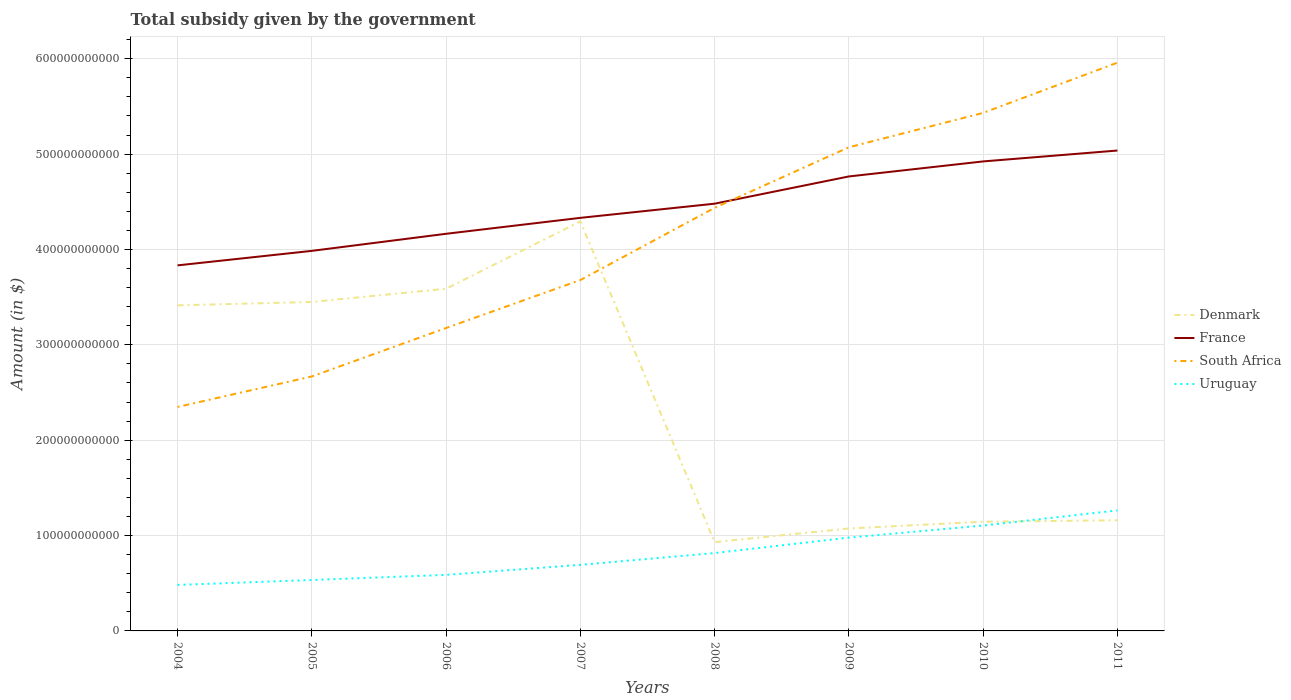Is the number of lines equal to the number of legend labels?
Ensure brevity in your answer.  Yes. Across all years, what is the maximum total revenue collected by the government in Denmark?
Ensure brevity in your answer.  9.31e+1. What is the total total revenue collected by the government in Denmark in the graph?
Give a very brief answer. -1.39e+1. What is the difference between the highest and the second highest total revenue collected by the government in France?
Keep it short and to the point. 1.20e+11. How many years are there in the graph?
Your answer should be compact. 8. What is the difference between two consecutive major ticks on the Y-axis?
Provide a succinct answer. 1.00e+11. Where does the legend appear in the graph?
Your answer should be very brief. Center right. How many legend labels are there?
Keep it short and to the point. 4. How are the legend labels stacked?
Your answer should be compact. Vertical. What is the title of the graph?
Offer a very short reply. Total subsidy given by the government. Does "Tunisia" appear as one of the legend labels in the graph?
Give a very brief answer. No. What is the label or title of the X-axis?
Offer a very short reply. Years. What is the label or title of the Y-axis?
Offer a very short reply. Amount (in $). What is the Amount (in $) in Denmark in 2004?
Your answer should be very brief. 3.41e+11. What is the Amount (in $) of France in 2004?
Provide a succinct answer. 3.83e+11. What is the Amount (in $) of South Africa in 2004?
Your answer should be compact. 2.35e+11. What is the Amount (in $) of Uruguay in 2004?
Provide a succinct answer. 4.82e+1. What is the Amount (in $) of Denmark in 2005?
Your answer should be compact. 3.45e+11. What is the Amount (in $) in France in 2005?
Provide a succinct answer. 3.99e+11. What is the Amount (in $) in South Africa in 2005?
Your answer should be very brief. 2.67e+11. What is the Amount (in $) in Uruguay in 2005?
Keep it short and to the point. 5.34e+1. What is the Amount (in $) in Denmark in 2006?
Your answer should be very brief. 3.59e+11. What is the Amount (in $) in France in 2006?
Provide a succinct answer. 4.16e+11. What is the Amount (in $) in South Africa in 2006?
Offer a very short reply. 3.18e+11. What is the Amount (in $) in Uruguay in 2006?
Provide a short and direct response. 5.88e+1. What is the Amount (in $) of Denmark in 2007?
Your answer should be compact. 4.29e+11. What is the Amount (in $) in France in 2007?
Provide a short and direct response. 4.33e+11. What is the Amount (in $) of South Africa in 2007?
Offer a terse response. 3.68e+11. What is the Amount (in $) in Uruguay in 2007?
Keep it short and to the point. 6.93e+1. What is the Amount (in $) in Denmark in 2008?
Your answer should be compact. 9.31e+1. What is the Amount (in $) in France in 2008?
Your response must be concise. 4.48e+11. What is the Amount (in $) in South Africa in 2008?
Your answer should be very brief. 4.44e+11. What is the Amount (in $) in Uruguay in 2008?
Your answer should be compact. 8.17e+1. What is the Amount (in $) in Denmark in 2009?
Provide a short and direct response. 1.07e+11. What is the Amount (in $) of France in 2009?
Your answer should be compact. 4.77e+11. What is the Amount (in $) of South Africa in 2009?
Provide a succinct answer. 5.07e+11. What is the Amount (in $) of Uruguay in 2009?
Keep it short and to the point. 9.79e+1. What is the Amount (in $) in Denmark in 2010?
Offer a terse response. 1.15e+11. What is the Amount (in $) of France in 2010?
Offer a very short reply. 4.92e+11. What is the Amount (in $) of South Africa in 2010?
Make the answer very short. 5.43e+11. What is the Amount (in $) of Uruguay in 2010?
Your answer should be very brief. 1.11e+11. What is the Amount (in $) of Denmark in 2011?
Offer a terse response. 1.16e+11. What is the Amount (in $) in France in 2011?
Provide a short and direct response. 5.04e+11. What is the Amount (in $) of South Africa in 2011?
Make the answer very short. 5.96e+11. What is the Amount (in $) of Uruguay in 2011?
Your response must be concise. 1.26e+11. Across all years, what is the maximum Amount (in $) of Denmark?
Provide a succinct answer. 4.29e+11. Across all years, what is the maximum Amount (in $) in France?
Provide a short and direct response. 5.04e+11. Across all years, what is the maximum Amount (in $) of South Africa?
Your answer should be compact. 5.96e+11. Across all years, what is the maximum Amount (in $) of Uruguay?
Offer a terse response. 1.26e+11. Across all years, what is the minimum Amount (in $) of Denmark?
Offer a very short reply. 9.31e+1. Across all years, what is the minimum Amount (in $) of France?
Give a very brief answer. 3.83e+11. Across all years, what is the minimum Amount (in $) of South Africa?
Your answer should be very brief. 2.35e+11. Across all years, what is the minimum Amount (in $) of Uruguay?
Offer a very short reply. 4.82e+1. What is the total Amount (in $) in Denmark in the graph?
Provide a succinct answer. 1.91e+12. What is the total Amount (in $) in France in the graph?
Offer a terse response. 3.55e+12. What is the total Amount (in $) in South Africa in the graph?
Offer a very short reply. 3.28e+12. What is the total Amount (in $) in Uruguay in the graph?
Provide a succinct answer. 6.46e+11. What is the difference between the Amount (in $) of Denmark in 2004 and that in 2005?
Provide a short and direct response. -3.54e+09. What is the difference between the Amount (in $) in France in 2004 and that in 2005?
Offer a very short reply. -1.52e+1. What is the difference between the Amount (in $) in South Africa in 2004 and that in 2005?
Ensure brevity in your answer.  -3.20e+1. What is the difference between the Amount (in $) of Uruguay in 2004 and that in 2005?
Make the answer very short. -5.17e+09. What is the difference between the Amount (in $) of Denmark in 2004 and that in 2006?
Provide a short and direct response. -1.74e+1. What is the difference between the Amount (in $) in France in 2004 and that in 2006?
Your response must be concise. -3.31e+1. What is the difference between the Amount (in $) in South Africa in 2004 and that in 2006?
Provide a short and direct response. -8.28e+1. What is the difference between the Amount (in $) in Uruguay in 2004 and that in 2006?
Provide a short and direct response. -1.06e+1. What is the difference between the Amount (in $) of Denmark in 2004 and that in 2007?
Provide a succinct answer. -8.80e+1. What is the difference between the Amount (in $) in France in 2004 and that in 2007?
Your answer should be compact. -4.98e+1. What is the difference between the Amount (in $) of South Africa in 2004 and that in 2007?
Your answer should be very brief. -1.33e+11. What is the difference between the Amount (in $) of Uruguay in 2004 and that in 2007?
Provide a succinct answer. -2.10e+1. What is the difference between the Amount (in $) in Denmark in 2004 and that in 2008?
Offer a terse response. 2.48e+11. What is the difference between the Amount (in $) in France in 2004 and that in 2008?
Give a very brief answer. -6.47e+1. What is the difference between the Amount (in $) of South Africa in 2004 and that in 2008?
Keep it short and to the point. -2.09e+11. What is the difference between the Amount (in $) of Uruguay in 2004 and that in 2008?
Your response must be concise. -3.34e+1. What is the difference between the Amount (in $) of Denmark in 2004 and that in 2009?
Your answer should be compact. 2.34e+11. What is the difference between the Amount (in $) of France in 2004 and that in 2009?
Give a very brief answer. -9.32e+1. What is the difference between the Amount (in $) of South Africa in 2004 and that in 2009?
Your response must be concise. -2.72e+11. What is the difference between the Amount (in $) of Uruguay in 2004 and that in 2009?
Your answer should be compact. -4.96e+1. What is the difference between the Amount (in $) of Denmark in 2004 and that in 2010?
Your response must be concise. 2.27e+11. What is the difference between the Amount (in $) of France in 2004 and that in 2010?
Your answer should be very brief. -1.09e+11. What is the difference between the Amount (in $) in South Africa in 2004 and that in 2010?
Provide a short and direct response. -3.08e+11. What is the difference between the Amount (in $) of Uruguay in 2004 and that in 2010?
Your response must be concise. -6.23e+1. What is the difference between the Amount (in $) in Denmark in 2004 and that in 2011?
Give a very brief answer. 2.25e+11. What is the difference between the Amount (in $) of France in 2004 and that in 2011?
Your response must be concise. -1.20e+11. What is the difference between the Amount (in $) of South Africa in 2004 and that in 2011?
Provide a succinct answer. -3.61e+11. What is the difference between the Amount (in $) of Uruguay in 2004 and that in 2011?
Make the answer very short. -7.81e+1. What is the difference between the Amount (in $) in Denmark in 2005 and that in 2006?
Give a very brief answer. -1.39e+1. What is the difference between the Amount (in $) in France in 2005 and that in 2006?
Ensure brevity in your answer.  -1.79e+1. What is the difference between the Amount (in $) in South Africa in 2005 and that in 2006?
Provide a short and direct response. -5.08e+1. What is the difference between the Amount (in $) of Uruguay in 2005 and that in 2006?
Your answer should be very brief. -5.38e+09. What is the difference between the Amount (in $) of Denmark in 2005 and that in 2007?
Provide a succinct answer. -8.45e+1. What is the difference between the Amount (in $) of France in 2005 and that in 2007?
Provide a succinct answer. -3.46e+1. What is the difference between the Amount (in $) of South Africa in 2005 and that in 2007?
Ensure brevity in your answer.  -1.01e+11. What is the difference between the Amount (in $) of Uruguay in 2005 and that in 2007?
Your answer should be compact. -1.58e+1. What is the difference between the Amount (in $) in Denmark in 2005 and that in 2008?
Keep it short and to the point. 2.52e+11. What is the difference between the Amount (in $) of France in 2005 and that in 2008?
Your answer should be compact. -4.95e+1. What is the difference between the Amount (in $) in South Africa in 2005 and that in 2008?
Give a very brief answer. -1.77e+11. What is the difference between the Amount (in $) in Uruguay in 2005 and that in 2008?
Provide a short and direct response. -2.82e+1. What is the difference between the Amount (in $) of Denmark in 2005 and that in 2009?
Keep it short and to the point. 2.38e+11. What is the difference between the Amount (in $) of France in 2005 and that in 2009?
Offer a terse response. -7.80e+1. What is the difference between the Amount (in $) in South Africa in 2005 and that in 2009?
Keep it short and to the point. -2.40e+11. What is the difference between the Amount (in $) in Uruguay in 2005 and that in 2009?
Your answer should be compact. -4.44e+1. What is the difference between the Amount (in $) of Denmark in 2005 and that in 2010?
Provide a short and direct response. 2.30e+11. What is the difference between the Amount (in $) in France in 2005 and that in 2010?
Provide a succinct answer. -9.38e+1. What is the difference between the Amount (in $) of South Africa in 2005 and that in 2010?
Provide a succinct answer. -2.76e+11. What is the difference between the Amount (in $) of Uruguay in 2005 and that in 2010?
Your response must be concise. -5.71e+1. What is the difference between the Amount (in $) of Denmark in 2005 and that in 2011?
Keep it short and to the point. 2.29e+11. What is the difference between the Amount (in $) in France in 2005 and that in 2011?
Keep it short and to the point. -1.05e+11. What is the difference between the Amount (in $) of South Africa in 2005 and that in 2011?
Make the answer very short. -3.29e+11. What is the difference between the Amount (in $) of Uruguay in 2005 and that in 2011?
Give a very brief answer. -7.30e+1. What is the difference between the Amount (in $) of Denmark in 2006 and that in 2007?
Give a very brief answer. -7.06e+1. What is the difference between the Amount (in $) in France in 2006 and that in 2007?
Your answer should be very brief. -1.67e+1. What is the difference between the Amount (in $) in South Africa in 2006 and that in 2007?
Your response must be concise. -5.03e+1. What is the difference between the Amount (in $) of Uruguay in 2006 and that in 2007?
Offer a very short reply. -1.05e+1. What is the difference between the Amount (in $) of Denmark in 2006 and that in 2008?
Keep it short and to the point. 2.66e+11. What is the difference between the Amount (in $) in France in 2006 and that in 2008?
Your answer should be compact. -3.16e+1. What is the difference between the Amount (in $) in South Africa in 2006 and that in 2008?
Ensure brevity in your answer.  -1.26e+11. What is the difference between the Amount (in $) in Uruguay in 2006 and that in 2008?
Make the answer very short. -2.29e+1. What is the difference between the Amount (in $) of Denmark in 2006 and that in 2009?
Provide a succinct answer. 2.51e+11. What is the difference between the Amount (in $) in France in 2006 and that in 2009?
Give a very brief answer. -6.01e+1. What is the difference between the Amount (in $) of South Africa in 2006 and that in 2009?
Keep it short and to the point. -1.90e+11. What is the difference between the Amount (in $) in Uruguay in 2006 and that in 2009?
Your response must be concise. -3.91e+1. What is the difference between the Amount (in $) in Denmark in 2006 and that in 2010?
Give a very brief answer. 2.44e+11. What is the difference between the Amount (in $) in France in 2006 and that in 2010?
Ensure brevity in your answer.  -7.59e+1. What is the difference between the Amount (in $) of South Africa in 2006 and that in 2010?
Keep it short and to the point. -2.26e+11. What is the difference between the Amount (in $) in Uruguay in 2006 and that in 2010?
Offer a very short reply. -5.17e+1. What is the difference between the Amount (in $) of Denmark in 2006 and that in 2011?
Provide a short and direct response. 2.43e+11. What is the difference between the Amount (in $) of France in 2006 and that in 2011?
Offer a very short reply. -8.73e+1. What is the difference between the Amount (in $) in South Africa in 2006 and that in 2011?
Your answer should be compact. -2.78e+11. What is the difference between the Amount (in $) of Uruguay in 2006 and that in 2011?
Keep it short and to the point. -6.76e+1. What is the difference between the Amount (in $) in Denmark in 2007 and that in 2008?
Offer a terse response. 3.36e+11. What is the difference between the Amount (in $) of France in 2007 and that in 2008?
Your answer should be very brief. -1.49e+1. What is the difference between the Amount (in $) in South Africa in 2007 and that in 2008?
Make the answer very short. -7.57e+1. What is the difference between the Amount (in $) of Uruguay in 2007 and that in 2008?
Provide a succinct answer. -1.24e+1. What is the difference between the Amount (in $) in Denmark in 2007 and that in 2009?
Your answer should be very brief. 3.22e+11. What is the difference between the Amount (in $) of France in 2007 and that in 2009?
Your answer should be compact. -4.34e+1. What is the difference between the Amount (in $) of South Africa in 2007 and that in 2009?
Keep it short and to the point. -1.39e+11. What is the difference between the Amount (in $) of Uruguay in 2007 and that in 2009?
Your response must be concise. -2.86e+1. What is the difference between the Amount (in $) of Denmark in 2007 and that in 2010?
Keep it short and to the point. 3.15e+11. What is the difference between the Amount (in $) in France in 2007 and that in 2010?
Your answer should be very brief. -5.92e+1. What is the difference between the Amount (in $) of South Africa in 2007 and that in 2010?
Make the answer very short. -1.75e+11. What is the difference between the Amount (in $) in Uruguay in 2007 and that in 2010?
Ensure brevity in your answer.  -4.12e+1. What is the difference between the Amount (in $) of Denmark in 2007 and that in 2011?
Offer a terse response. 3.13e+11. What is the difference between the Amount (in $) of France in 2007 and that in 2011?
Make the answer very short. -7.06e+1. What is the difference between the Amount (in $) in South Africa in 2007 and that in 2011?
Offer a terse response. -2.28e+11. What is the difference between the Amount (in $) of Uruguay in 2007 and that in 2011?
Offer a terse response. -5.71e+1. What is the difference between the Amount (in $) in Denmark in 2008 and that in 2009?
Keep it short and to the point. -1.43e+1. What is the difference between the Amount (in $) of France in 2008 and that in 2009?
Your answer should be compact. -2.86e+1. What is the difference between the Amount (in $) in South Africa in 2008 and that in 2009?
Your answer should be compact. -6.35e+1. What is the difference between the Amount (in $) of Uruguay in 2008 and that in 2009?
Give a very brief answer. -1.62e+1. What is the difference between the Amount (in $) in Denmark in 2008 and that in 2010?
Your response must be concise. -2.14e+1. What is the difference between the Amount (in $) of France in 2008 and that in 2010?
Offer a very short reply. -4.43e+1. What is the difference between the Amount (in $) in South Africa in 2008 and that in 2010?
Offer a very short reply. -9.96e+1. What is the difference between the Amount (in $) in Uruguay in 2008 and that in 2010?
Your answer should be compact. -2.89e+1. What is the difference between the Amount (in $) in Denmark in 2008 and that in 2011?
Make the answer very short. -2.29e+1. What is the difference between the Amount (in $) in France in 2008 and that in 2011?
Give a very brief answer. -5.57e+1. What is the difference between the Amount (in $) in South Africa in 2008 and that in 2011?
Make the answer very short. -1.52e+11. What is the difference between the Amount (in $) in Uruguay in 2008 and that in 2011?
Make the answer very short. -4.47e+1. What is the difference between the Amount (in $) in Denmark in 2009 and that in 2010?
Offer a terse response. -7.08e+09. What is the difference between the Amount (in $) in France in 2009 and that in 2010?
Your response must be concise. -1.57e+1. What is the difference between the Amount (in $) of South Africa in 2009 and that in 2010?
Your answer should be very brief. -3.61e+1. What is the difference between the Amount (in $) of Uruguay in 2009 and that in 2010?
Provide a short and direct response. -1.26e+1. What is the difference between the Amount (in $) in Denmark in 2009 and that in 2011?
Offer a very short reply. -8.61e+09. What is the difference between the Amount (in $) of France in 2009 and that in 2011?
Your response must be concise. -2.72e+1. What is the difference between the Amount (in $) in South Africa in 2009 and that in 2011?
Provide a short and direct response. -8.87e+1. What is the difference between the Amount (in $) of Uruguay in 2009 and that in 2011?
Your answer should be very brief. -2.85e+1. What is the difference between the Amount (in $) of Denmark in 2010 and that in 2011?
Give a very brief answer. -1.53e+09. What is the difference between the Amount (in $) of France in 2010 and that in 2011?
Provide a short and direct response. -1.14e+1. What is the difference between the Amount (in $) in South Africa in 2010 and that in 2011?
Make the answer very short. -5.26e+1. What is the difference between the Amount (in $) of Uruguay in 2010 and that in 2011?
Give a very brief answer. -1.59e+1. What is the difference between the Amount (in $) in Denmark in 2004 and the Amount (in $) in France in 2005?
Your answer should be very brief. -5.71e+1. What is the difference between the Amount (in $) in Denmark in 2004 and the Amount (in $) in South Africa in 2005?
Give a very brief answer. 7.46e+1. What is the difference between the Amount (in $) of Denmark in 2004 and the Amount (in $) of Uruguay in 2005?
Your response must be concise. 2.88e+11. What is the difference between the Amount (in $) of France in 2004 and the Amount (in $) of South Africa in 2005?
Keep it short and to the point. 1.16e+11. What is the difference between the Amount (in $) of France in 2004 and the Amount (in $) of Uruguay in 2005?
Keep it short and to the point. 3.30e+11. What is the difference between the Amount (in $) in South Africa in 2004 and the Amount (in $) in Uruguay in 2005?
Ensure brevity in your answer.  1.81e+11. What is the difference between the Amount (in $) of Denmark in 2004 and the Amount (in $) of France in 2006?
Give a very brief answer. -7.50e+1. What is the difference between the Amount (in $) in Denmark in 2004 and the Amount (in $) in South Africa in 2006?
Provide a short and direct response. 2.38e+1. What is the difference between the Amount (in $) of Denmark in 2004 and the Amount (in $) of Uruguay in 2006?
Provide a succinct answer. 2.83e+11. What is the difference between the Amount (in $) of France in 2004 and the Amount (in $) of South Africa in 2006?
Your answer should be very brief. 6.57e+1. What is the difference between the Amount (in $) of France in 2004 and the Amount (in $) of Uruguay in 2006?
Offer a terse response. 3.25e+11. What is the difference between the Amount (in $) of South Africa in 2004 and the Amount (in $) of Uruguay in 2006?
Your response must be concise. 1.76e+11. What is the difference between the Amount (in $) in Denmark in 2004 and the Amount (in $) in France in 2007?
Your answer should be compact. -9.17e+1. What is the difference between the Amount (in $) in Denmark in 2004 and the Amount (in $) in South Africa in 2007?
Offer a terse response. -2.65e+1. What is the difference between the Amount (in $) of Denmark in 2004 and the Amount (in $) of Uruguay in 2007?
Offer a very short reply. 2.72e+11. What is the difference between the Amount (in $) in France in 2004 and the Amount (in $) in South Africa in 2007?
Provide a short and direct response. 1.54e+1. What is the difference between the Amount (in $) of France in 2004 and the Amount (in $) of Uruguay in 2007?
Provide a short and direct response. 3.14e+11. What is the difference between the Amount (in $) in South Africa in 2004 and the Amount (in $) in Uruguay in 2007?
Provide a succinct answer. 1.66e+11. What is the difference between the Amount (in $) of Denmark in 2004 and the Amount (in $) of France in 2008?
Ensure brevity in your answer.  -1.07e+11. What is the difference between the Amount (in $) in Denmark in 2004 and the Amount (in $) in South Africa in 2008?
Your answer should be very brief. -1.02e+11. What is the difference between the Amount (in $) in Denmark in 2004 and the Amount (in $) in Uruguay in 2008?
Offer a very short reply. 2.60e+11. What is the difference between the Amount (in $) in France in 2004 and the Amount (in $) in South Africa in 2008?
Your response must be concise. -6.03e+1. What is the difference between the Amount (in $) of France in 2004 and the Amount (in $) of Uruguay in 2008?
Give a very brief answer. 3.02e+11. What is the difference between the Amount (in $) of South Africa in 2004 and the Amount (in $) of Uruguay in 2008?
Provide a short and direct response. 1.53e+11. What is the difference between the Amount (in $) of Denmark in 2004 and the Amount (in $) of France in 2009?
Give a very brief answer. -1.35e+11. What is the difference between the Amount (in $) of Denmark in 2004 and the Amount (in $) of South Africa in 2009?
Make the answer very short. -1.66e+11. What is the difference between the Amount (in $) in Denmark in 2004 and the Amount (in $) in Uruguay in 2009?
Give a very brief answer. 2.44e+11. What is the difference between the Amount (in $) of France in 2004 and the Amount (in $) of South Africa in 2009?
Offer a terse response. -1.24e+11. What is the difference between the Amount (in $) in France in 2004 and the Amount (in $) in Uruguay in 2009?
Ensure brevity in your answer.  2.85e+11. What is the difference between the Amount (in $) in South Africa in 2004 and the Amount (in $) in Uruguay in 2009?
Your response must be concise. 1.37e+11. What is the difference between the Amount (in $) of Denmark in 2004 and the Amount (in $) of France in 2010?
Make the answer very short. -1.51e+11. What is the difference between the Amount (in $) in Denmark in 2004 and the Amount (in $) in South Africa in 2010?
Ensure brevity in your answer.  -2.02e+11. What is the difference between the Amount (in $) in Denmark in 2004 and the Amount (in $) in Uruguay in 2010?
Your answer should be compact. 2.31e+11. What is the difference between the Amount (in $) in France in 2004 and the Amount (in $) in South Africa in 2010?
Your answer should be compact. -1.60e+11. What is the difference between the Amount (in $) in France in 2004 and the Amount (in $) in Uruguay in 2010?
Your answer should be very brief. 2.73e+11. What is the difference between the Amount (in $) of South Africa in 2004 and the Amount (in $) of Uruguay in 2010?
Your answer should be compact. 1.24e+11. What is the difference between the Amount (in $) in Denmark in 2004 and the Amount (in $) in France in 2011?
Provide a succinct answer. -1.62e+11. What is the difference between the Amount (in $) in Denmark in 2004 and the Amount (in $) in South Africa in 2011?
Keep it short and to the point. -2.54e+11. What is the difference between the Amount (in $) of Denmark in 2004 and the Amount (in $) of Uruguay in 2011?
Make the answer very short. 2.15e+11. What is the difference between the Amount (in $) of France in 2004 and the Amount (in $) of South Africa in 2011?
Your answer should be compact. -2.13e+11. What is the difference between the Amount (in $) of France in 2004 and the Amount (in $) of Uruguay in 2011?
Keep it short and to the point. 2.57e+11. What is the difference between the Amount (in $) in South Africa in 2004 and the Amount (in $) in Uruguay in 2011?
Offer a terse response. 1.08e+11. What is the difference between the Amount (in $) of Denmark in 2005 and the Amount (in $) of France in 2006?
Provide a short and direct response. -7.15e+1. What is the difference between the Amount (in $) in Denmark in 2005 and the Amount (in $) in South Africa in 2006?
Offer a terse response. 2.73e+1. What is the difference between the Amount (in $) in Denmark in 2005 and the Amount (in $) in Uruguay in 2006?
Your response must be concise. 2.86e+11. What is the difference between the Amount (in $) in France in 2005 and the Amount (in $) in South Africa in 2006?
Make the answer very short. 8.09e+1. What is the difference between the Amount (in $) in France in 2005 and the Amount (in $) in Uruguay in 2006?
Make the answer very short. 3.40e+11. What is the difference between the Amount (in $) in South Africa in 2005 and the Amount (in $) in Uruguay in 2006?
Your response must be concise. 2.08e+11. What is the difference between the Amount (in $) in Denmark in 2005 and the Amount (in $) in France in 2007?
Keep it short and to the point. -8.82e+1. What is the difference between the Amount (in $) in Denmark in 2005 and the Amount (in $) in South Africa in 2007?
Give a very brief answer. -2.30e+1. What is the difference between the Amount (in $) of Denmark in 2005 and the Amount (in $) of Uruguay in 2007?
Give a very brief answer. 2.76e+11. What is the difference between the Amount (in $) in France in 2005 and the Amount (in $) in South Africa in 2007?
Offer a very short reply. 3.06e+1. What is the difference between the Amount (in $) in France in 2005 and the Amount (in $) in Uruguay in 2007?
Offer a very short reply. 3.29e+11. What is the difference between the Amount (in $) in South Africa in 2005 and the Amount (in $) in Uruguay in 2007?
Ensure brevity in your answer.  1.98e+11. What is the difference between the Amount (in $) of Denmark in 2005 and the Amount (in $) of France in 2008?
Your answer should be compact. -1.03e+11. What is the difference between the Amount (in $) of Denmark in 2005 and the Amount (in $) of South Africa in 2008?
Provide a succinct answer. -9.87e+1. What is the difference between the Amount (in $) of Denmark in 2005 and the Amount (in $) of Uruguay in 2008?
Keep it short and to the point. 2.63e+11. What is the difference between the Amount (in $) of France in 2005 and the Amount (in $) of South Africa in 2008?
Give a very brief answer. -4.51e+1. What is the difference between the Amount (in $) in France in 2005 and the Amount (in $) in Uruguay in 2008?
Offer a terse response. 3.17e+11. What is the difference between the Amount (in $) in South Africa in 2005 and the Amount (in $) in Uruguay in 2008?
Your response must be concise. 1.85e+11. What is the difference between the Amount (in $) of Denmark in 2005 and the Amount (in $) of France in 2009?
Provide a short and direct response. -1.32e+11. What is the difference between the Amount (in $) of Denmark in 2005 and the Amount (in $) of South Africa in 2009?
Provide a succinct answer. -1.62e+11. What is the difference between the Amount (in $) of Denmark in 2005 and the Amount (in $) of Uruguay in 2009?
Make the answer very short. 2.47e+11. What is the difference between the Amount (in $) of France in 2005 and the Amount (in $) of South Africa in 2009?
Offer a very short reply. -1.09e+11. What is the difference between the Amount (in $) in France in 2005 and the Amount (in $) in Uruguay in 2009?
Offer a terse response. 3.01e+11. What is the difference between the Amount (in $) in South Africa in 2005 and the Amount (in $) in Uruguay in 2009?
Provide a short and direct response. 1.69e+11. What is the difference between the Amount (in $) of Denmark in 2005 and the Amount (in $) of France in 2010?
Keep it short and to the point. -1.47e+11. What is the difference between the Amount (in $) of Denmark in 2005 and the Amount (in $) of South Africa in 2010?
Offer a very short reply. -1.98e+11. What is the difference between the Amount (in $) in Denmark in 2005 and the Amount (in $) in Uruguay in 2010?
Your response must be concise. 2.34e+11. What is the difference between the Amount (in $) in France in 2005 and the Amount (in $) in South Africa in 2010?
Provide a short and direct response. -1.45e+11. What is the difference between the Amount (in $) in France in 2005 and the Amount (in $) in Uruguay in 2010?
Provide a short and direct response. 2.88e+11. What is the difference between the Amount (in $) of South Africa in 2005 and the Amount (in $) of Uruguay in 2010?
Your answer should be compact. 1.56e+11. What is the difference between the Amount (in $) in Denmark in 2005 and the Amount (in $) in France in 2011?
Give a very brief answer. -1.59e+11. What is the difference between the Amount (in $) in Denmark in 2005 and the Amount (in $) in South Africa in 2011?
Offer a very short reply. -2.51e+11. What is the difference between the Amount (in $) in Denmark in 2005 and the Amount (in $) in Uruguay in 2011?
Your answer should be compact. 2.19e+11. What is the difference between the Amount (in $) of France in 2005 and the Amount (in $) of South Africa in 2011?
Keep it short and to the point. -1.97e+11. What is the difference between the Amount (in $) in France in 2005 and the Amount (in $) in Uruguay in 2011?
Offer a very short reply. 2.72e+11. What is the difference between the Amount (in $) of South Africa in 2005 and the Amount (in $) of Uruguay in 2011?
Keep it short and to the point. 1.40e+11. What is the difference between the Amount (in $) of Denmark in 2006 and the Amount (in $) of France in 2007?
Make the answer very short. -7.43e+1. What is the difference between the Amount (in $) of Denmark in 2006 and the Amount (in $) of South Africa in 2007?
Offer a very short reply. -9.12e+09. What is the difference between the Amount (in $) in Denmark in 2006 and the Amount (in $) in Uruguay in 2007?
Offer a terse response. 2.90e+11. What is the difference between the Amount (in $) in France in 2006 and the Amount (in $) in South Africa in 2007?
Offer a very short reply. 4.85e+1. What is the difference between the Amount (in $) in France in 2006 and the Amount (in $) in Uruguay in 2007?
Provide a short and direct response. 3.47e+11. What is the difference between the Amount (in $) in South Africa in 2006 and the Amount (in $) in Uruguay in 2007?
Your response must be concise. 2.48e+11. What is the difference between the Amount (in $) of Denmark in 2006 and the Amount (in $) of France in 2008?
Ensure brevity in your answer.  -8.92e+1. What is the difference between the Amount (in $) in Denmark in 2006 and the Amount (in $) in South Africa in 2008?
Keep it short and to the point. -8.49e+1. What is the difference between the Amount (in $) in Denmark in 2006 and the Amount (in $) in Uruguay in 2008?
Offer a terse response. 2.77e+11. What is the difference between the Amount (in $) in France in 2006 and the Amount (in $) in South Africa in 2008?
Your answer should be compact. -2.72e+1. What is the difference between the Amount (in $) in France in 2006 and the Amount (in $) in Uruguay in 2008?
Offer a very short reply. 3.35e+11. What is the difference between the Amount (in $) of South Africa in 2006 and the Amount (in $) of Uruguay in 2008?
Keep it short and to the point. 2.36e+11. What is the difference between the Amount (in $) of Denmark in 2006 and the Amount (in $) of France in 2009?
Your answer should be compact. -1.18e+11. What is the difference between the Amount (in $) in Denmark in 2006 and the Amount (in $) in South Africa in 2009?
Offer a terse response. -1.48e+11. What is the difference between the Amount (in $) in Denmark in 2006 and the Amount (in $) in Uruguay in 2009?
Offer a very short reply. 2.61e+11. What is the difference between the Amount (in $) in France in 2006 and the Amount (in $) in South Africa in 2009?
Give a very brief answer. -9.07e+1. What is the difference between the Amount (in $) in France in 2006 and the Amount (in $) in Uruguay in 2009?
Give a very brief answer. 3.19e+11. What is the difference between the Amount (in $) in South Africa in 2006 and the Amount (in $) in Uruguay in 2009?
Provide a short and direct response. 2.20e+11. What is the difference between the Amount (in $) of Denmark in 2006 and the Amount (in $) of France in 2010?
Keep it short and to the point. -1.34e+11. What is the difference between the Amount (in $) in Denmark in 2006 and the Amount (in $) in South Africa in 2010?
Provide a succinct answer. -1.84e+11. What is the difference between the Amount (in $) of Denmark in 2006 and the Amount (in $) of Uruguay in 2010?
Your response must be concise. 2.48e+11. What is the difference between the Amount (in $) of France in 2006 and the Amount (in $) of South Africa in 2010?
Your answer should be very brief. -1.27e+11. What is the difference between the Amount (in $) of France in 2006 and the Amount (in $) of Uruguay in 2010?
Your answer should be very brief. 3.06e+11. What is the difference between the Amount (in $) in South Africa in 2006 and the Amount (in $) in Uruguay in 2010?
Your answer should be very brief. 2.07e+11. What is the difference between the Amount (in $) in Denmark in 2006 and the Amount (in $) in France in 2011?
Your answer should be compact. -1.45e+11. What is the difference between the Amount (in $) of Denmark in 2006 and the Amount (in $) of South Africa in 2011?
Ensure brevity in your answer.  -2.37e+11. What is the difference between the Amount (in $) in Denmark in 2006 and the Amount (in $) in Uruguay in 2011?
Offer a very short reply. 2.32e+11. What is the difference between the Amount (in $) of France in 2006 and the Amount (in $) of South Africa in 2011?
Give a very brief answer. -1.79e+11. What is the difference between the Amount (in $) in France in 2006 and the Amount (in $) in Uruguay in 2011?
Keep it short and to the point. 2.90e+11. What is the difference between the Amount (in $) of South Africa in 2006 and the Amount (in $) of Uruguay in 2011?
Give a very brief answer. 1.91e+11. What is the difference between the Amount (in $) of Denmark in 2007 and the Amount (in $) of France in 2008?
Your answer should be very brief. -1.86e+1. What is the difference between the Amount (in $) in Denmark in 2007 and the Amount (in $) in South Africa in 2008?
Offer a very short reply. -1.42e+1. What is the difference between the Amount (in $) of Denmark in 2007 and the Amount (in $) of Uruguay in 2008?
Offer a terse response. 3.48e+11. What is the difference between the Amount (in $) of France in 2007 and the Amount (in $) of South Africa in 2008?
Make the answer very short. -1.05e+1. What is the difference between the Amount (in $) in France in 2007 and the Amount (in $) in Uruguay in 2008?
Offer a terse response. 3.51e+11. What is the difference between the Amount (in $) in South Africa in 2007 and the Amount (in $) in Uruguay in 2008?
Your answer should be compact. 2.86e+11. What is the difference between the Amount (in $) in Denmark in 2007 and the Amount (in $) in France in 2009?
Keep it short and to the point. -4.71e+1. What is the difference between the Amount (in $) of Denmark in 2007 and the Amount (in $) of South Africa in 2009?
Provide a short and direct response. -7.77e+1. What is the difference between the Amount (in $) in Denmark in 2007 and the Amount (in $) in Uruguay in 2009?
Keep it short and to the point. 3.32e+11. What is the difference between the Amount (in $) in France in 2007 and the Amount (in $) in South Africa in 2009?
Make the answer very short. -7.40e+1. What is the difference between the Amount (in $) in France in 2007 and the Amount (in $) in Uruguay in 2009?
Offer a very short reply. 3.35e+11. What is the difference between the Amount (in $) of South Africa in 2007 and the Amount (in $) of Uruguay in 2009?
Give a very brief answer. 2.70e+11. What is the difference between the Amount (in $) of Denmark in 2007 and the Amount (in $) of France in 2010?
Give a very brief answer. -6.29e+1. What is the difference between the Amount (in $) of Denmark in 2007 and the Amount (in $) of South Africa in 2010?
Provide a short and direct response. -1.14e+11. What is the difference between the Amount (in $) of Denmark in 2007 and the Amount (in $) of Uruguay in 2010?
Keep it short and to the point. 3.19e+11. What is the difference between the Amount (in $) in France in 2007 and the Amount (in $) in South Africa in 2010?
Your answer should be compact. -1.10e+11. What is the difference between the Amount (in $) in France in 2007 and the Amount (in $) in Uruguay in 2010?
Offer a terse response. 3.23e+11. What is the difference between the Amount (in $) of South Africa in 2007 and the Amount (in $) of Uruguay in 2010?
Keep it short and to the point. 2.57e+11. What is the difference between the Amount (in $) of Denmark in 2007 and the Amount (in $) of France in 2011?
Offer a terse response. -7.43e+1. What is the difference between the Amount (in $) of Denmark in 2007 and the Amount (in $) of South Africa in 2011?
Give a very brief answer. -1.66e+11. What is the difference between the Amount (in $) of Denmark in 2007 and the Amount (in $) of Uruguay in 2011?
Keep it short and to the point. 3.03e+11. What is the difference between the Amount (in $) in France in 2007 and the Amount (in $) in South Africa in 2011?
Your answer should be very brief. -1.63e+11. What is the difference between the Amount (in $) in France in 2007 and the Amount (in $) in Uruguay in 2011?
Offer a terse response. 3.07e+11. What is the difference between the Amount (in $) in South Africa in 2007 and the Amount (in $) in Uruguay in 2011?
Your answer should be very brief. 2.42e+11. What is the difference between the Amount (in $) of Denmark in 2008 and the Amount (in $) of France in 2009?
Make the answer very short. -3.83e+11. What is the difference between the Amount (in $) in Denmark in 2008 and the Amount (in $) in South Africa in 2009?
Give a very brief answer. -4.14e+11. What is the difference between the Amount (in $) in Denmark in 2008 and the Amount (in $) in Uruguay in 2009?
Offer a terse response. -4.73e+09. What is the difference between the Amount (in $) in France in 2008 and the Amount (in $) in South Africa in 2009?
Provide a succinct answer. -5.92e+1. What is the difference between the Amount (in $) of France in 2008 and the Amount (in $) of Uruguay in 2009?
Ensure brevity in your answer.  3.50e+11. What is the difference between the Amount (in $) of South Africa in 2008 and the Amount (in $) of Uruguay in 2009?
Offer a terse response. 3.46e+11. What is the difference between the Amount (in $) in Denmark in 2008 and the Amount (in $) in France in 2010?
Your answer should be very brief. -3.99e+11. What is the difference between the Amount (in $) of Denmark in 2008 and the Amount (in $) of South Africa in 2010?
Make the answer very short. -4.50e+11. What is the difference between the Amount (in $) of Denmark in 2008 and the Amount (in $) of Uruguay in 2010?
Make the answer very short. -1.74e+1. What is the difference between the Amount (in $) in France in 2008 and the Amount (in $) in South Africa in 2010?
Give a very brief answer. -9.52e+1. What is the difference between the Amount (in $) in France in 2008 and the Amount (in $) in Uruguay in 2010?
Provide a succinct answer. 3.37e+11. What is the difference between the Amount (in $) of South Africa in 2008 and the Amount (in $) of Uruguay in 2010?
Your answer should be compact. 3.33e+11. What is the difference between the Amount (in $) in Denmark in 2008 and the Amount (in $) in France in 2011?
Your answer should be very brief. -4.11e+11. What is the difference between the Amount (in $) in Denmark in 2008 and the Amount (in $) in South Africa in 2011?
Give a very brief answer. -5.03e+11. What is the difference between the Amount (in $) in Denmark in 2008 and the Amount (in $) in Uruguay in 2011?
Give a very brief answer. -3.33e+1. What is the difference between the Amount (in $) in France in 2008 and the Amount (in $) in South Africa in 2011?
Keep it short and to the point. -1.48e+11. What is the difference between the Amount (in $) in France in 2008 and the Amount (in $) in Uruguay in 2011?
Offer a terse response. 3.22e+11. What is the difference between the Amount (in $) in South Africa in 2008 and the Amount (in $) in Uruguay in 2011?
Give a very brief answer. 3.17e+11. What is the difference between the Amount (in $) in Denmark in 2009 and the Amount (in $) in France in 2010?
Your answer should be very brief. -3.85e+11. What is the difference between the Amount (in $) in Denmark in 2009 and the Amount (in $) in South Africa in 2010?
Provide a succinct answer. -4.36e+11. What is the difference between the Amount (in $) of Denmark in 2009 and the Amount (in $) of Uruguay in 2010?
Keep it short and to the point. -3.08e+09. What is the difference between the Amount (in $) of France in 2009 and the Amount (in $) of South Africa in 2010?
Provide a short and direct response. -6.67e+1. What is the difference between the Amount (in $) in France in 2009 and the Amount (in $) in Uruguay in 2010?
Provide a succinct answer. 3.66e+11. What is the difference between the Amount (in $) of South Africa in 2009 and the Amount (in $) of Uruguay in 2010?
Ensure brevity in your answer.  3.97e+11. What is the difference between the Amount (in $) in Denmark in 2009 and the Amount (in $) in France in 2011?
Your answer should be very brief. -3.96e+11. What is the difference between the Amount (in $) in Denmark in 2009 and the Amount (in $) in South Africa in 2011?
Provide a short and direct response. -4.88e+11. What is the difference between the Amount (in $) in Denmark in 2009 and the Amount (in $) in Uruguay in 2011?
Ensure brevity in your answer.  -1.90e+1. What is the difference between the Amount (in $) in France in 2009 and the Amount (in $) in South Africa in 2011?
Offer a very short reply. -1.19e+11. What is the difference between the Amount (in $) of France in 2009 and the Amount (in $) of Uruguay in 2011?
Your response must be concise. 3.50e+11. What is the difference between the Amount (in $) of South Africa in 2009 and the Amount (in $) of Uruguay in 2011?
Make the answer very short. 3.81e+11. What is the difference between the Amount (in $) of Denmark in 2010 and the Amount (in $) of France in 2011?
Give a very brief answer. -3.89e+11. What is the difference between the Amount (in $) of Denmark in 2010 and the Amount (in $) of South Africa in 2011?
Give a very brief answer. -4.81e+11. What is the difference between the Amount (in $) in Denmark in 2010 and the Amount (in $) in Uruguay in 2011?
Offer a terse response. -1.19e+1. What is the difference between the Amount (in $) in France in 2010 and the Amount (in $) in South Africa in 2011?
Your response must be concise. -1.04e+11. What is the difference between the Amount (in $) in France in 2010 and the Amount (in $) in Uruguay in 2011?
Provide a succinct answer. 3.66e+11. What is the difference between the Amount (in $) in South Africa in 2010 and the Amount (in $) in Uruguay in 2011?
Your answer should be compact. 4.17e+11. What is the average Amount (in $) in Denmark per year?
Your response must be concise. 2.38e+11. What is the average Amount (in $) in France per year?
Ensure brevity in your answer.  4.44e+11. What is the average Amount (in $) of South Africa per year?
Your answer should be compact. 4.10e+11. What is the average Amount (in $) of Uruguay per year?
Keep it short and to the point. 8.08e+1. In the year 2004, what is the difference between the Amount (in $) in Denmark and Amount (in $) in France?
Your answer should be compact. -4.19e+1. In the year 2004, what is the difference between the Amount (in $) of Denmark and Amount (in $) of South Africa?
Ensure brevity in your answer.  1.07e+11. In the year 2004, what is the difference between the Amount (in $) of Denmark and Amount (in $) of Uruguay?
Your answer should be compact. 2.93e+11. In the year 2004, what is the difference between the Amount (in $) of France and Amount (in $) of South Africa?
Your answer should be compact. 1.48e+11. In the year 2004, what is the difference between the Amount (in $) in France and Amount (in $) in Uruguay?
Your answer should be compact. 3.35e+11. In the year 2004, what is the difference between the Amount (in $) in South Africa and Amount (in $) in Uruguay?
Make the answer very short. 1.87e+11. In the year 2005, what is the difference between the Amount (in $) in Denmark and Amount (in $) in France?
Your answer should be compact. -5.36e+1. In the year 2005, what is the difference between the Amount (in $) in Denmark and Amount (in $) in South Africa?
Give a very brief answer. 7.81e+1. In the year 2005, what is the difference between the Amount (in $) of Denmark and Amount (in $) of Uruguay?
Ensure brevity in your answer.  2.92e+11. In the year 2005, what is the difference between the Amount (in $) of France and Amount (in $) of South Africa?
Keep it short and to the point. 1.32e+11. In the year 2005, what is the difference between the Amount (in $) of France and Amount (in $) of Uruguay?
Provide a short and direct response. 3.45e+11. In the year 2005, what is the difference between the Amount (in $) in South Africa and Amount (in $) in Uruguay?
Provide a short and direct response. 2.13e+11. In the year 2006, what is the difference between the Amount (in $) in Denmark and Amount (in $) in France?
Your response must be concise. -5.76e+1. In the year 2006, what is the difference between the Amount (in $) in Denmark and Amount (in $) in South Africa?
Offer a terse response. 4.12e+1. In the year 2006, what is the difference between the Amount (in $) in Denmark and Amount (in $) in Uruguay?
Offer a terse response. 3.00e+11. In the year 2006, what is the difference between the Amount (in $) in France and Amount (in $) in South Africa?
Offer a terse response. 9.88e+1. In the year 2006, what is the difference between the Amount (in $) in France and Amount (in $) in Uruguay?
Make the answer very short. 3.58e+11. In the year 2006, what is the difference between the Amount (in $) in South Africa and Amount (in $) in Uruguay?
Make the answer very short. 2.59e+11. In the year 2007, what is the difference between the Amount (in $) in Denmark and Amount (in $) in France?
Provide a succinct answer. -3.71e+09. In the year 2007, what is the difference between the Amount (in $) in Denmark and Amount (in $) in South Africa?
Give a very brief answer. 6.15e+1. In the year 2007, what is the difference between the Amount (in $) in Denmark and Amount (in $) in Uruguay?
Ensure brevity in your answer.  3.60e+11. In the year 2007, what is the difference between the Amount (in $) of France and Amount (in $) of South Africa?
Offer a very short reply. 6.52e+1. In the year 2007, what is the difference between the Amount (in $) in France and Amount (in $) in Uruguay?
Ensure brevity in your answer.  3.64e+11. In the year 2007, what is the difference between the Amount (in $) in South Africa and Amount (in $) in Uruguay?
Offer a terse response. 2.99e+11. In the year 2008, what is the difference between the Amount (in $) of Denmark and Amount (in $) of France?
Offer a terse response. -3.55e+11. In the year 2008, what is the difference between the Amount (in $) in Denmark and Amount (in $) in South Africa?
Your response must be concise. -3.51e+11. In the year 2008, what is the difference between the Amount (in $) in Denmark and Amount (in $) in Uruguay?
Offer a very short reply. 1.15e+1. In the year 2008, what is the difference between the Amount (in $) in France and Amount (in $) in South Africa?
Your answer should be very brief. 4.34e+09. In the year 2008, what is the difference between the Amount (in $) of France and Amount (in $) of Uruguay?
Your answer should be compact. 3.66e+11. In the year 2008, what is the difference between the Amount (in $) of South Africa and Amount (in $) of Uruguay?
Give a very brief answer. 3.62e+11. In the year 2009, what is the difference between the Amount (in $) in Denmark and Amount (in $) in France?
Keep it short and to the point. -3.69e+11. In the year 2009, what is the difference between the Amount (in $) of Denmark and Amount (in $) of South Africa?
Give a very brief answer. -4.00e+11. In the year 2009, what is the difference between the Amount (in $) of Denmark and Amount (in $) of Uruguay?
Your answer should be very brief. 9.57e+09. In the year 2009, what is the difference between the Amount (in $) of France and Amount (in $) of South Africa?
Give a very brief answer. -3.06e+1. In the year 2009, what is the difference between the Amount (in $) of France and Amount (in $) of Uruguay?
Make the answer very short. 3.79e+11. In the year 2009, what is the difference between the Amount (in $) in South Africa and Amount (in $) in Uruguay?
Make the answer very short. 4.09e+11. In the year 2010, what is the difference between the Amount (in $) in Denmark and Amount (in $) in France?
Ensure brevity in your answer.  -3.78e+11. In the year 2010, what is the difference between the Amount (in $) in Denmark and Amount (in $) in South Africa?
Ensure brevity in your answer.  -4.29e+11. In the year 2010, what is the difference between the Amount (in $) in Denmark and Amount (in $) in Uruguay?
Your answer should be very brief. 4.01e+09. In the year 2010, what is the difference between the Amount (in $) in France and Amount (in $) in South Africa?
Offer a very short reply. -5.09e+1. In the year 2010, what is the difference between the Amount (in $) of France and Amount (in $) of Uruguay?
Keep it short and to the point. 3.82e+11. In the year 2010, what is the difference between the Amount (in $) in South Africa and Amount (in $) in Uruguay?
Your response must be concise. 4.33e+11. In the year 2011, what is the difference between the Amount (in $) of Denmark and Amount (in $) of France?
Ensure brevity in your answer.  -3.88e+11. In the year 2011, what is the difference between the Amount (in $) in Denmark and Amount (in $) in South Africa?
Offer a terse response. -4.80e+11. In the year 2011, what is the difference between the Amount (in $) of Denmark and Amount (in $) of Uruguay?
Your answer should be compact. -1.03e+1. In the year 2011, what is the difference between the Amount (in $) of France and Amount (in $) of South Africa?
Make the answer very short. -9.21e+1. In the year 2011, what is the difference between the Amount (in $) of France and Amount (in $) of Uruguay?
Provide a succinct answer. 3.77e+11. In the year 2011, what is the difference between the Amount (in $) in South Africa and Amount (in $) in Uruguay?
Offer a very short reply. 4.69e+11. What is the ratio of the Amount (in $) of Denmark in 2004 to that in 2005?
Your answer should be very brief. 0.99. What is the ratio of the Amount (in $) in France in 2004 to that in 2005?
Your answer should be very brief. 0.96. What is the ratio of the Amount (in $) of South Africa in 2004 to that in 2005?
Provide a short and direct response. 0.88. What is the ratio of the Amount (in $) of Uruguay in 2004 to that in 2005?
Your response must be concise. 0.9. What is the ratio of the Amount (in $) in Denmark in 2004 to that in 2006?
Give a very brief answer. 0.95. What is the ratio of the Amount (in $) of France in 2004 to that in 2006?
Give a very brief answer. 0.92. What is the ratio of the Amount (in $) in South Africa in 2004 to that in 2006?
Your answer should be compact. 0.74. What is the ratio of the Amount (in $) of Uruguay in 2004 to that in 2006?
Provide a succinct answer. 0.82. What is the ratio of the Amount (in $) of Denmark in 2004 to that in 2007?
Provide a short and direct response. 0.8. What is the ratio of the Amount (in $) in France in 2004 to that in 2007?
Your response must be concise. 0.89. What is the ratio of the Amount (in $) in South Africa in 2004 to that in 2007?
Give a very brief answer. 0.64. What is the ratio of the Amount (in $) of Uruguay in 2004 to that in 2007?
Keep it short and to the point. 0.7. What is the ratio of the Amount (in $) of Denmark in 2004 to that in 2008?
Ensure brevity in your answer.  3.67. What is the ratio of the Amount (in $) of France in 2004 to that in 2008?
Your answer should be very brief. 0.86. What is the ratio of the Amount (in $) of South Africa in 2004 to that in 2008?
Keep it short and to the point. 0.53. What is the ratio of the Amount (in $) of Uruguay in 2004 to that in 2008?
Make the answer very short. 0.59. What is the ratio of the Amount (in $) in Denmark in 2004 to that in 2009?
Offer a very short reply. 3.18. What is the ratio of the Amount (in $) in France in 2004 to that in 2009?
Ensure brevity in your answer.  0.8. What is the ratio of the Amount (in $) in South Africa in 2004 to that in 2009?
Offer a terse response. 0.46. What is the ratio of the Amount (in $) of Uruguay in 2004 to that in 2009?
Your answer should be very brief. 0.49. What is the ratio of the Amount (in $) of Denmark in 2004 to that in 2010?
Offer a terse response. 2.98. What is the ratio of the Amount (in $) in France in 2004 to that in 2010?
Make the answer very short. 0.78. What is the ratio of the Amount (in $) in South Africa in 2004 to that in 2010?
Ensure brevity in your answer.  0.43. What is the ratio of the Amount (in $) in Uruguay in 2004 to that in 2010?
Provide a succinct answer. 0.44. What is the ratio of the Amount (in $) of Denmark in 2004 to that in 2011?
Give a very brief answer. 2.94. What is the ratio of the Amount (in $) of France in 2004 to that in 2011?
Provide a short and direct response. 0.76. What is the ratio of the Amount (in $) of South Africa in 2004 to that in 2011?
Give a very brief answer. 0.39. What is the ratio of the Amount (in $) of Uruguay in 2004 to that in 2011?
Give a very brief answer. 0.38. What is the ratio of the Amount (in $) in Denmark in 2005 to that in 2006?
Offer a very short reply. 0.96. What is the ratio of the Amount (in $) of South Africa in 2005 to that in 2006?
Offer a very short reply. 0.84. What is the ratio of the Amount (in $) of Uruguay in 2005 to that in 2006?
Your answer should be very brief. 0.91. What is the ratio of the Amount (in $) in Denmark in 2005 to that in 2007?
Your answer should be very brief. 0.8. What is the ratio of the Amount (in $) of France in 2005 to that in 2007?
Offer a terse response. 0.92. What is the ratio of the Amount (in $) in South Africa in 2005 to that in 2007?
Ensure brevity in your answer.  0.73. What is the ratio of the Amount (in $) in Uruguay in 2005 to that in 2007?
Your answer should be compact. 0.77. What is the ratio of the Amount (in $) of Denmark in 2005 to that in 2008?
Provide a short and direct response. 3.7. What is the ratio of the Amount (in $) in France in 2005 to that in 2008?
Provide a succinct answer. 0.89. What is the ratio of the Amount (in $) in South Africa in 2005 to that in 2008?
Your response must be concise. 0.6. What is the ratio of the Amount (in $) in Uruguay in 2005 to that in 2008?
Your answer should be compact. 0.65. What is the ratio of the Amount (in $) of Denmark in 2005 to that in 2009?
Your answer should be very brief. 3.21. What is the ratio of the Amount (in $) of France in 2005 to that in 2009?
Your answer should be very brief. 0.84. What is the ratio of the Amount (in $) of South Africa in 2005 to that in 2009?
Make the answer very short. 0.53. What is the ratio of the Amount (in $) of Uruguay in 2005 to that in 2009?
Offer a very short reply. 0.55. What is the ratio of the Amount (in $) of Denmark in 2005 to that in 2010?
Offer a very short reply. 3.01. What is the ratio of the Amount (in $) of France in 2005 to that in 2010?
Give a very brief answer. 0.81. What is the ratio of the Amount (in $) of South Africa in 2005 to that in 2010?
Ensure brevity in your answer.  0.49. What is the ratio of the Amount (in $) in Uruguay in 2005 to that in 2010?
Ensure brevity in your answer.  0.48. What is the ratio of the Amount (in $) in Denmark in 2005 to that in 2011?
Your answer should be very brief. 2.97. What is the ratio of the Amount (in $) of France in 2005 to that in 2011?
Give a very brief answer. 0.79. What is the ratio of the Amount (in $) in South Africa in 2005 to that in 2011?
Your response must be concise. 0.45. What is the ratio of the Amount (in $) of Uruguay in 2005 to that in 2011?
Keep it short and to the point. 0.42. What is the ratio of the Amount (in $) of Denmark in 2006 to that in 2007?
Give a very brief answer. 0.84. What is the ratio of the Amount (in $) in France in 2006 to that in 2007?
Your answer should be very brief. 0.96. What is the ratio of the Amount (in $) of South Africa in 2006 to that in 2007?
Ensure brevity in your answer.  0.86. What is the ratio of the Amount (in $) in Uruguay in 2006 to that in 2007?
Make the answer very short. 0.85. What is the ratio of the Amount (in $) of Denmark in 2006 to that in 2008?
Ensure brevity in your answer.  3.85. What is the ratio of the Amount (in $) in France in 2006 to that in 2008?
Offer a terse response. 0.93. What is the ratio of the Amount (in $) of South Africa in 2006 to that in 2008?
Your response must be concise. 0.72. What is the ratio of the Amount (in $) of Uruguay in 2006 to that in 2008?
Offer a terse response. 0.72. What is the ratio of the Amount (in $) of Denmark in 2006 to that in 2009?
Give a very brief answer. 3.34. What is the ratio of the Amount (in $) of France in 2006 to that in 2009?
Offer a very short reply. 0.87. What is the ratio of the Amount (in $) of South Africa in 2006 to that in 2009?
Keep it short and to the point. 0.63. What is the ratio of the Amount (in $) of Uruguay in 2006 to that in 2009?
Your answer should be very brief. 0.6. What is the ratio of the Amount (in $) in Denmark in 2006 to that in 2010?
Your answer should be very brief. 3.13. What is the ratio of the Amount (in $) of France in 2006 to that in 2010?
Ensure brevity in your answer.  0.85. What is the ratio of the Amount (in $) of South Africa in 2006 to that in 2010?
Offer a terse response. 0.58. What is the ratio of the Amount (in $) in Uruguay in 2006 to that in 2010?
Your answer should be compact. 0.53. What is the ratio of the Amount (in $) of Denmark in 2006 to that in 2011?
Offer a terse response. 3.09. What is the ratio of the Amount (in $) in France in 2006 to that in 2011?
Offer a terse response. 0.83. What is the ratio of the Amount (in $) in South Africa in 2006 to that in 2011?
Your answer should be very brief. 0.53. What is the ratio of the Amount (in $) of Uruguay in 2006 to that in 2011?
Make the answer very short. 0.47. What is the ratio of the Amount (in $) of Denmark in 2007 to that in 2008?
Keep it short and to the point. 4.61. What is the ratio of the Amount (in $) of France in 2007 to that in 2008?
Offer a terse response. 0.97. What is the ratio of the Amount (in $) in South Africa in 2007 to that in 2008?
Provide a short and direct response. 0.83. What is the ratio of the Amount (in $) of Uruguay in 2007 to that in 2008?
Your answer should be compact. 0.85. What is the ratio of the Amount (in $) in Denmark in 2007 to that in 2009?
Give a very brief answer. 4. What is the ratio of the Amount (in $) of France in 2007 to that in 2009?
Give a very brief answer. 0.91. What is the ratio of the Amount (in $) in South Africa in 2007 to that in 2009?
Your response must be concise. 0.73. What is the ratio of the Amount (in $) of Uruguay in 2007 to that in 2009?
Provide a succinct answer. 0.71. What is the ratio of the Amount (in $) of Denmark in 2007 to that in 2010?
Give a very brief answer. 3.75. What is the ratio of the Amount (in $) in France in 2007 to that in 2010?
Offer a very short reply. 0.88. What is the ratio of the Amount (in $) in South Africa in 2007 to that in 2010?
Ensure brevity in your answer.  0.68. What is the ratio of the Amount (in $) in Uruguay in 2007 to that in 2010?
Your answer should be very brief. 0.63. What is the ratio of the Amount (in $) of Denmark in 2007 to that in 2011?
Make the answer very short. 3.7. What is the ratio of the Amount (in $) in France in 2007 to that in 2011?
Your answer should be compact. 0.86. What is the ratio of the Amount (in $) in South Africa in 2007 to that in 2011?
Provide a short and direct response. 0.62. What is the ratio of the Amount (in $) in Uruguay in 2007 to that in 2011?
Provide a succinct answer. 0.55. What is the ratio of the Amount (in $) in Denmark in 2008 to that in 2009?
Offer a very short reply. 0.87. What is the ratio of the Amount (in $) of France in 2008 to that in 2009?
Provide a succinct answer. 0.94. What is the ratio of the Amount (in $) of South Africa in 2008 to that in 2009?
Offer a very short reply. 0.87. What is the ratio of the Amount (in $) in Uruguay in 2008 to that in 2009?
Your answer should be very brief. 0.83. What is the ratio of the Amount (in $) in Denmark in 2008 to that in 2010?
Keep it short and to the point. 0.81. What is the ratio of the Amount (in $) of France in 2008 to that in 2010?
Provide a succinct answer. 0.91. What is the ratio of the Amount (in $) of South Africa in 2008 to that in 2010?
Your answer should be very brief. 0.82. What is the ratio of the Amount (in $) in Uruguay in 2008 to that in 2010?
Provide a succinct answer. 0.74. What is the ratio of the Amount (in $) of Denmark in 2008 to that in 2011?
Give a very brief answer. 0.8. What is the ratio of the Amount (in $) in France in 2008 to that in 2011?
Provide a short and direct response. 0.89. What is the ratio of the Amount (in $) of South Africa in 2008 to that in 2011?
Make the answer very short. 0.74. What is the ratio of the Amount (in $) in Uruguay in 2008 to that in 2011?
Give a very brief answer. 0.65. What is the ratio of the Amount (in $) of Denmark in 2009 to that in 2010?
Keep it short and to the point. 0.94. What is the ratio of the Amount (in $) in France in 2009 to that in 2010?
Make the answer very short. 0.97. What is the ratio of the Amount (in $) of South Africa in 2009 to that in 2010?
Make the answer very short. 0.93. What is the ratio of the Amount (in $) of Uruguay in 2009 to that in 2010?
Your answer should be very brief. 0.89. What is the ratio of the Amount (in $) of Denmark in 2009 to that in 2011?
Your answer should be compact. 0.93. What is the ratio of the Amount (in $) in France in 2009 to that in 2011?
Offer a very short reply. 0.95. What is the ratio of the Amount (in $) in South Africa in 2009 to that in 2011?
Your answer should be compact. 0.85. What is the ratio of the Amount (in $) in Uruguay in 2009 to that in 2011?
Provide a succinct answer. 0.77. What is the ratio of the Amount (in $) in France in 2010 to that in 2011?
Provide a short and direct response. 0.98. What is the ratio of the Amount (in $) in South Africa in 2010 to that in 2011?
Your answer should be compact. 0.91. What is the ratio of the Amount (in $) of Uruguay in 2010 to that in 2011?
Your answer should be very brief. 0.87. What is the difference between the highest and the second highest Amount (in $) in Denmark?
Keep it short and to the point. 7.06e+1. What is the difference between the highest and the second highest Amount (in $) of France?
Offer a very short reply. 1.14e+1. What is the difference between the highest and the second highest Amount (in $) in South Africa?
Offer a very short reply. 5.26e+1. What is the difference between the highest and the second highest Amount (in $) in Uruguay?
Provide a succinct answer. 1.59e+1. What is the difference between the highest and the lowest Amount (in $) of Denmark?
Your answer should be compact. 3.36e+11. What is the difference between the highest and the lowest Amount (in $) of France?
Your answer should be compact. 1.20e+11. What is the difference between the highest and the lowest Amount (in $) of South Africa?
Offer a terse response. 3.61e+11. What is the difference between the highest and the lowest Amount (in $) in Uruguay?
Ensure brevity in your answer.  7.81e+1. 